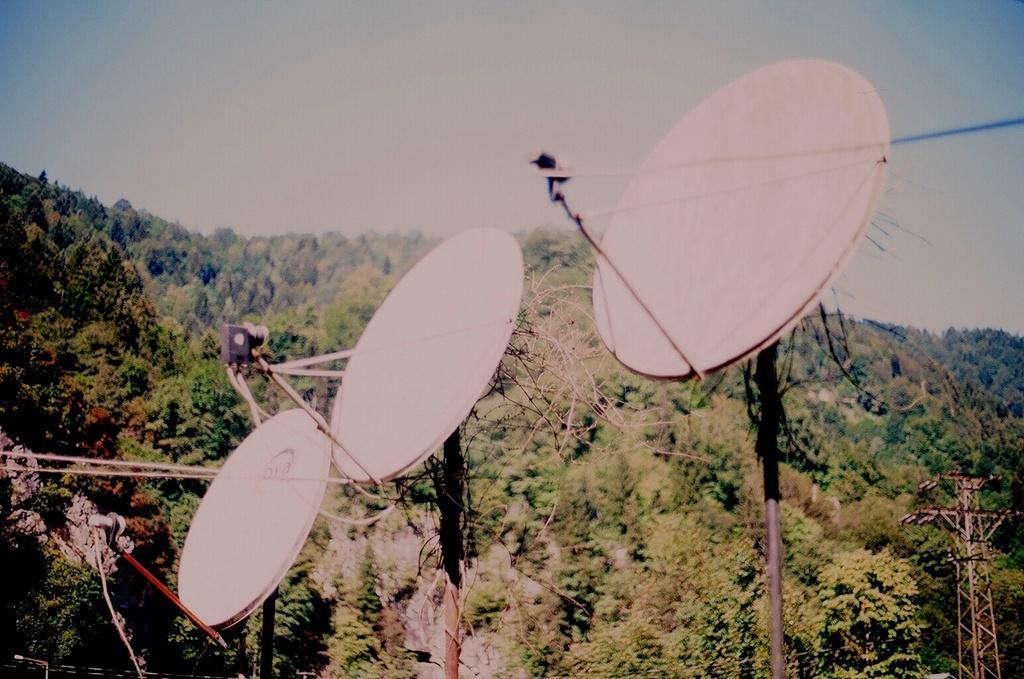In one or two sentences, can you explain what this image depicts? In this image I can see few dish antennas, wires, towers and few trees. The sky is in blue color. 